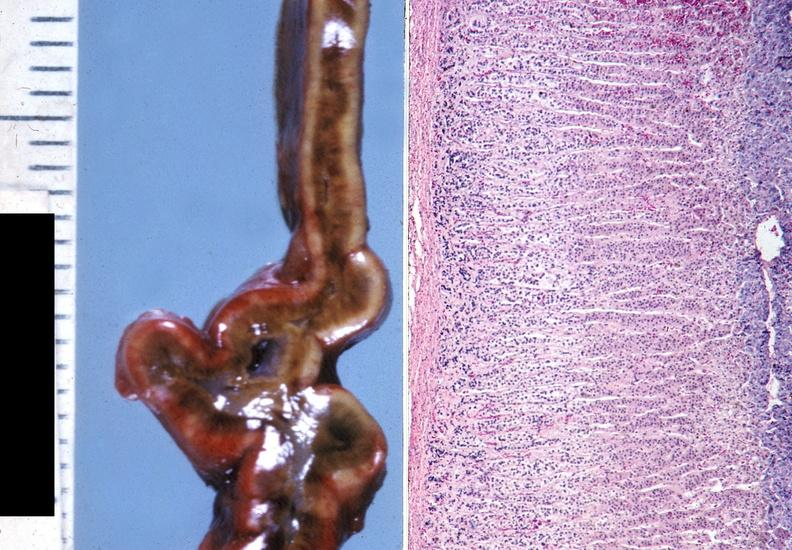s fibrinous peritonitis present?
Answer the question using a single word or phrase. No 